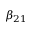<formula> <loc_0><loc_0><loc_500><loc_500>\beta _ { 2 1 }</formula> 